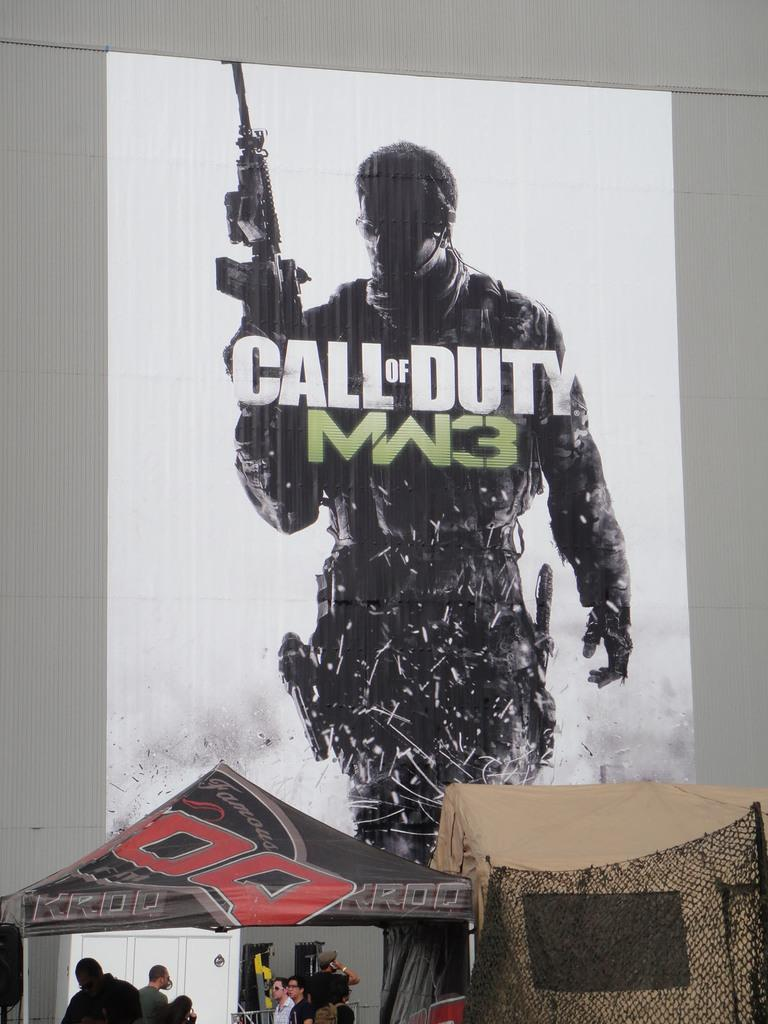Who or what can be seen in the image? There are people in the image. What structures are visible in the image? There are tents in the image. What can be seen in the background of the image? There is a poster on a wall in the background of the image. What type of button is being used to hold the tents together in the image? There is no button visible in the image; the tents are likely held together by other means, such as ropes or poles. Can you see any hills in the image? There is no mention of hills in the provided facts, and no hills are visible in the image. 